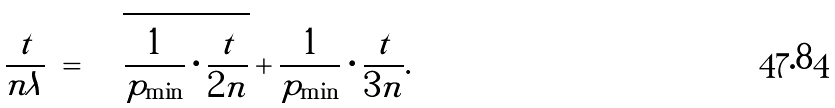Convert formula to latex. <formula><loc_0><loc_0><loc_500><loc_500>\frac { t } { n \lambda } \ = \ \sqrt { \frac { 1 } { p _ { \min } } \cdot \frac { t } { 2 n } } + \frac { 1 } { p _ { \min } } \cdot \frac { t } { 3 n } .</formula> 